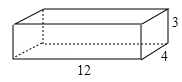What kind of material and tools do you think would be needed to make a box like the one in the image? Based on the image, to create a wooden box of that type, you would need sheets of quality wood, such as plywood or a similar sturdy material. Tools required could include a saw for cutting the wood to size, a measuring tape for accuracy, nails or wood screws for assembly, a hammer or screwdriver, and possibly wood glue for reinforcement. Additionally, sandpaper could be used to smooth the edges, and varnish or paint could be applied for a finished look. 